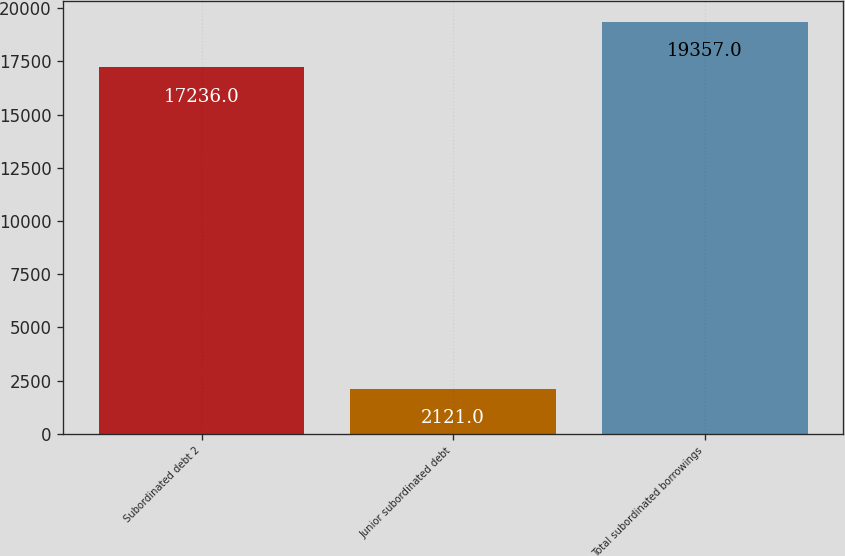Convert chart to OTSL. <chart><loc_0><loc_0><loc_500><loc_500><bar_chart><fcel>Subordinated debt 2<fcel>Junior subordinated debt<fcel>Total subordinated borrowings<nl><fcel>17236<fcel>2121<fcel>19357<nl></chart> 